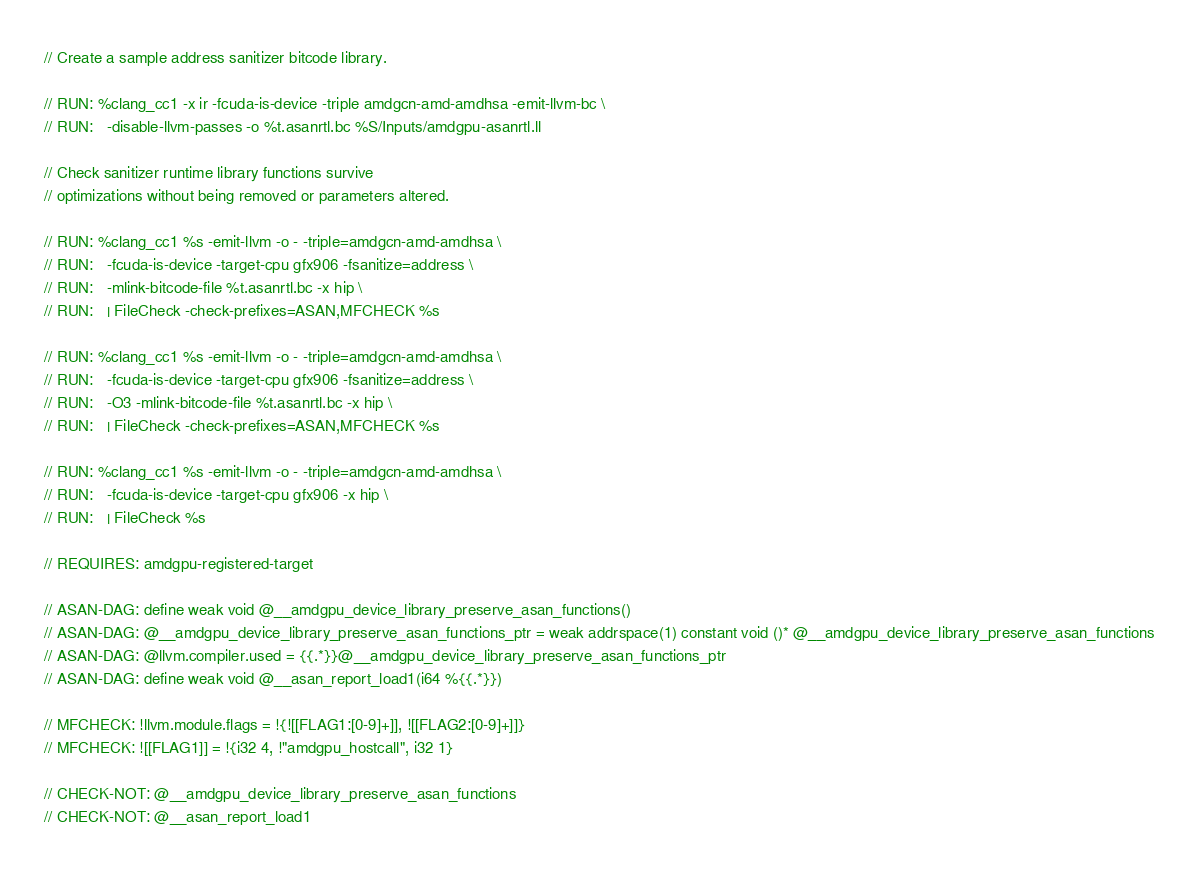<code> <loc_0><loc_0><loc_500><loc_500><_Cuda_>// Create a sample address sanitizer bitcode library.

// RUN: %clang_cc1 -x ir -fcuda-is-device -triple amdgcn-amd-amdhsa -emit-llvm-bc \
// RUN:   -disable-llvm-passes -o %t.asanrtl.bc %S/Inputs/amdgpu-asanrtl.ll

// Check sanitizer runtime library functions survive
// optimizations without being removed or parameters altered.

// RUN: %clang_cc1 %s -emit-llvm -o - -triple=amdgcn-amd-amdhsa \
// RUN:   -fcuda-is-device -target-cpu gfx906 -fsanitize=address \
// RUN:   -mlink-bitcode-file %t.asanrtl.bc -x hip \
// RUN:   | FileCheck -check-prefixes=ASAN,MFCHECK %s

// RUN: %clang_cc1 %s -emit-llvm -o - -triple=amdgcn-amd-amdhsa \
// RUN:   -fcuda-is-device -target-cpu gfx906 -fsanitize=address \
// RUN:   -O3 -mlink-bitcode-file %t.asanrtl.bc -x hip \
// RUN:   | FileCheck -check-prefixes=ASAN,MFCHECK %s

// RUN: %clang_cc1 %s -emit-llvm -o - -triple=amdgcn-amd-amdhsa \
// RUN:   -fcuda-is-device -target-cpu gfx906 -x hip \
// RUN:   | FileCheck %s

// REQUIRES: amdgpu-registered-target

// ASAN-DAG: define weak void @__amdgpu_device_library_preserve_asan_functions()
// ASAN-DAG: @__amdgpu_device_library_preserve_asan_functions_ptr = weak addrspace(1) constant void ()* @__amdgpu_device_library_preserve_asan_functions
// ASAN-DAG: @llvm.compiler.used = {{.*}}@__amdgpu_device_library_preserve_asan_functions_ptr
// ASAN-DAG: define weak void @__asan_report_load1(i64 %{{.*}})

// MFCHECK: !llvm.module.flags = !{![[FLAG1:[0-9]+]], ![[FLAG2:[0-9]+]]}
// MFCHECK: ![[FLAG1]] = !{i32 4, !"amdgpu_hostcall", i32 1}

// CHECK-NOT: @__amdgpu_device_library_preserve_asan_functions
// CHECK-NOT: @__asan_report_load1
</code> 